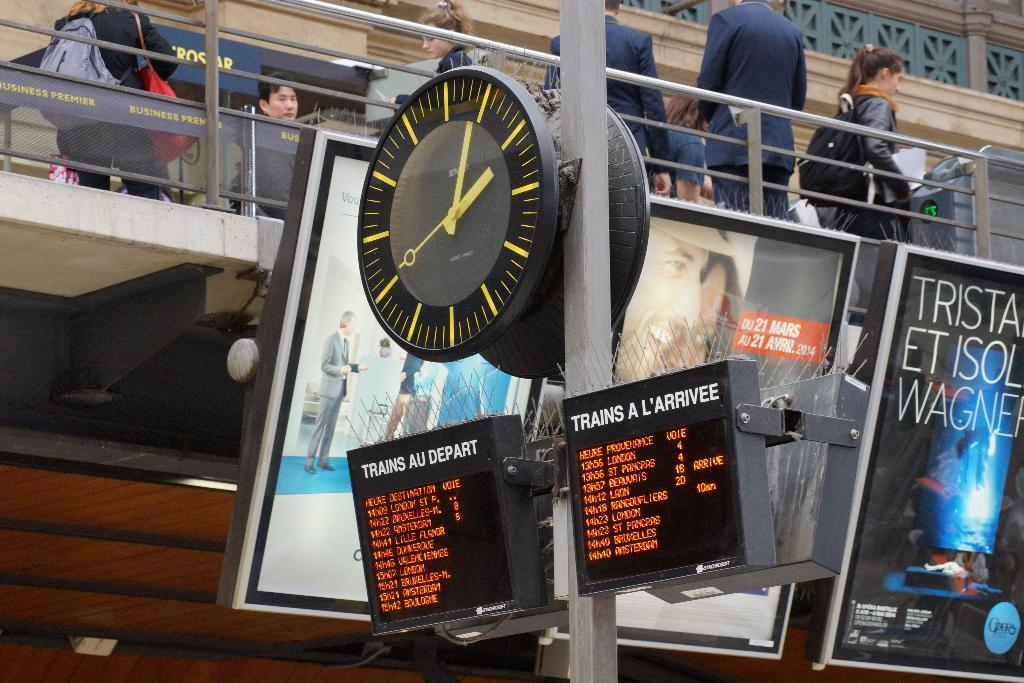<image>
Offer a succinct explanation of the picture presented. A clock showing 2 o clock with the sign closest to it saying Business Premier. 